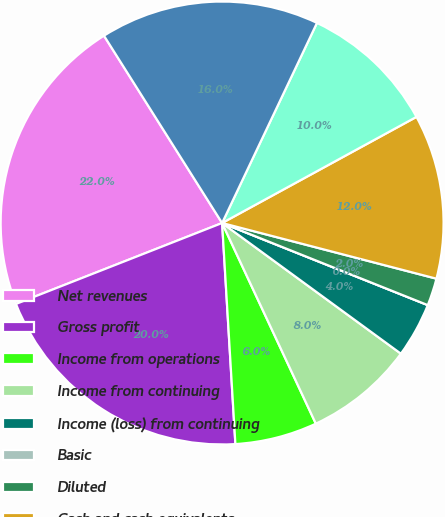Convert chart to OTSL. <chart><loc_0><loc_0><loc_500><loc_500><pie_chart><fcel>Net revenues<fcel>Gross profit<fcel>Income from operations<fcel>Income from continuing<fcel>Income (loss) from continuing<fcel>Basic<fcel>Diluted<fcel>Cash and cash equivalents<fcel>Short-term investments<fcel>Long-term investments<nl><fcel>22.0%<fcel>20.0%<fcel>6.0%<fcel>8.0%<fcel>4.0%<fcel>0.0%<fcel>2.0%<fcel>12.0%<fcel>10.0%<fcel>16.0%<nl></chart> 